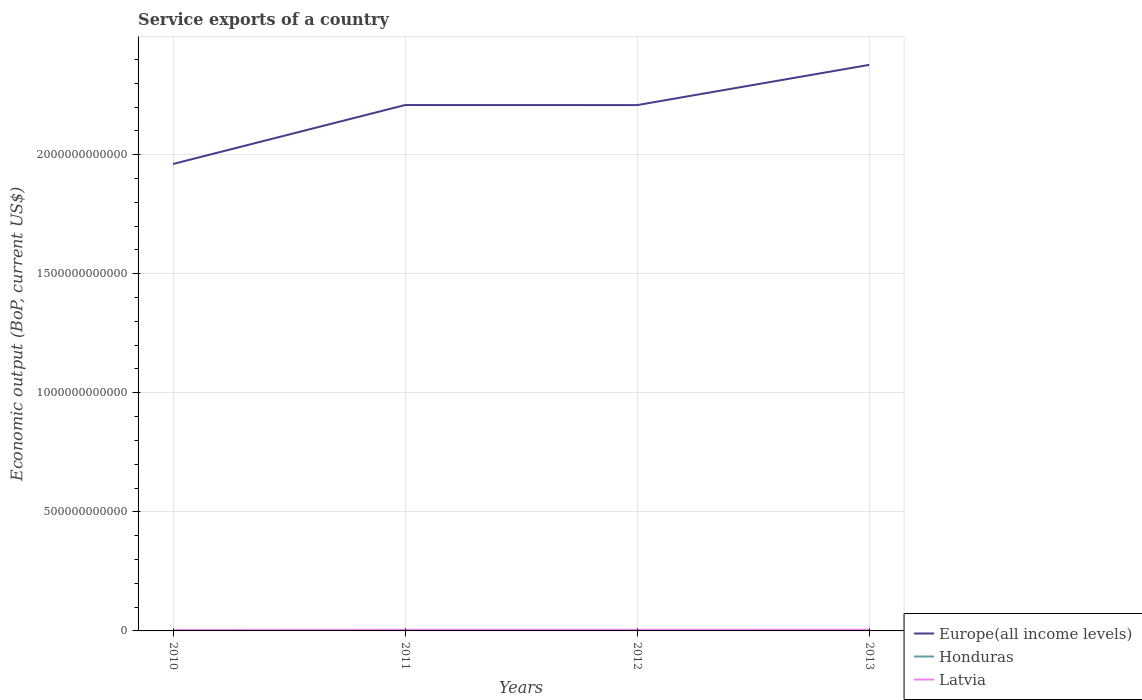Is the number of lines equal to the number of legend labels?
Your response must be concise. Yes. Across all years, what is the maximum service exports in Europe(all income levels)?
Give a very brief answer. 1.96e+12. In which year was the service exports in Honduras maximum?
Offer a terse response. 2010. What is the total service exports in Honduras in the graph?
Provide a short and direct response. -1.46e+08. What is the difference between the highest and the second highest service exports in Latvia?
Offer a very short reply. 1.14e+09. What is the difference between the highest and the lowest service exports in Latvia?
Provide a succinct answer. 3. Is the service exports in Latvia strictly greater than the service exports in Honduras over the years?
Your answer should be very brief. No. How many lines are there?
Your answer should be compact. 3. What is the difference between two consecutive major ticks on the Y-axis?
Make the answer very short. 5.00e+11. How many legend labels are there?
Ensure brevity in your answer.  3. What is the title of the graph?
Provide a succinct answer. Service exports of a country. What is the label or title of the Y-axis?
Ensure brevity in your answer.  Economic output (BoP, current US$). What is the Economic output (BoP, current US$) in Europe(all income levels) in 2010?
Offer a terse response. 1.96e+12. What is the Economic output (BoP, current US$) of Honduras in 2010?
Provide a succinct answer. 2.11e+09. What is the Economic output (BoP, current US$) in Latvia in 2010?
Ensure brevity in your answer.  4.04e+09. What is the Economic output (BoP, current US$) of Europe(all income levels) in 2011?
Give a very brief answer. 2.21e+12. What is the Economic output (BoP, current US$) in Honduras in 2011?
Provide a succinct answer. 2.25e+09. What is the Economic output (BoP, current US$) of Latvia in 2011?
Offer a very short reply. 4.83e+09. What is the Economic output (BoP, current US$) in Europe(all income levels) in 2012?
Make the answer very short. 2.21e+12. What is the Economic output (BoP, current US$) in Honduras in 2012?
Provide a short and direct response. 2.26e+09. What is the Economic output (BoP, current US$) in Latvia in 2012?
Keep it short and to the point. 4.84e+09. What is the Economic output (BoP, current US$) of Europe(all income levels) in 2013?
Offer a very short reply. 2.38e+12. What is the Economic output (BoP, current US$) of Honduras in 2013?
Provide a succinct answer. 2.42e+09. What is the Economic output (BoP, current US$) of Latvia in 2013?
Give a very brief answer. 5.18e+09. Across all years, what is the maximum Economic output (BoP, current US$) in Europe(all income levels)?
Ensure brevity in your answer.  2.38e+12. Across all years, what is the maximum Economic output (BoP, current US$) of Honduras?
Offer a very short reply. 2.42e+09. Across all years, what is the maximum Economic output (BoP, current US$) of Latvia?
Keep it short and to the point. 5.18e+09. Across all years, what is the minimum Economic output (BoP, current US$) of Europe(all income levels)?
Offer a very short reply. 1.96e+12. Across all years, what is the minimum Economic output (BoP, current US$) in Honduras?
Offer a terse response. 2.11e+09. Across all years, what is the minimum Economic output (BoP, current US$) of Latvia?
Your answer should be compact. 4.04e+09. What is the total Economic output (BoP, current US$) in Europe(all income levels) in the graph?
Your answer should be very brief. 8.75e+12. What is the total Economic output (BoP, current US$) of Honduras in the graph?
Provide a succinct answer. 9.04e+09. What is the total Economic output (BoP, current US$) of Latvia in the graph?
Your response must be concise. 1.89e+1. What is the difference between the Economic output (BoP, current US$) in Europe(all income levels) in 2010 and that in 2011?
Your answer should be very brief. -2.48e+11. What is the difference between the Economic output (BoP, current US$) in Honduras in 2010 and that in 2011?
Ensure brevity in your answer.  -1.46e+08. What is the difference between the Economic output (BoP, current US$) in Latvia in 2010 and that in 2011?
Your answer should be very brief. -7.87e+08. What is the difference between the Economic output (BoP, current US$) in Europe(all income levels) in 2010 and that in 2012?
Offer a terse response. -2.47e+11. What is the difference between the Economic output (BoP, current US$) in Honduras in 2010 and that in 2012?
Ensure brevity in your answer.  -1.50e+08. What is the difference between the Economic output (BoP, current US$) of Latvia in 2010 and that in 2012?
Offer a terse response. -7.97e+08. What is the difference between the Economic output (BoP, current US$) in Europe(all income levels) in 2010 and that in 2013?
Your answer should be very brief. -4.16e+11. What is the difference between the Economic output (BoP, current US$) in Honduras in 2010 and that in 2013?
Offer a terse response. -3.17e+08. What is the difference between the Economic output (BoP, current US$) in Latvia in 2010 and that in 2013?
Ensure brevity in your answer.  -1.14e+09. What is the difference between the Economic output (BoP, current US$) in Europe(all income levels) in 2011 and that in 2012?
Offer a very short reply. 3.03e+08. What is the difference between the Economic output (BoP, current US$) of Honduras in 2011 and that in 2012?
Ensure brevity in your answer.  -3.58e+06. What is the difference between the Economic output (BoP, current US$) in Latvia in 2011 and that in 2012?
Your answer should be compact. -1.06e+07. What is the difference between the Economic output (BoP, current US$) of Europe(all income levels) in 2011 and that in 2013?
Ensure brevity in your answer.  -1.69e+11. What is the difference between the Economic output (BoP, current US$) of Honduras in 2011 and that in 2013?
Give a very brief answer. -1.71e+08. What is the difference between the Economic output (BoP, current US$) in Latvia in 2011 and that in 2013?
Offer a terse response. -3.54e+08. What is the difference between the Economic output (BoP, current US$) of Europe(all income levels) in 2012 and that in 2013?
Ensure brevity in your answer.  -1.69e+11. What is the difference between the Economic output (BoP, current US$) of Honduras in 2012 and that in 2013?
Your answer should be very brief. -1.67e+08. What is the difference between the Economic output (BoP, current US$) of Latvia in 2012 and that in 2013?
Your answer should be very brief. -3.43e+08. What is the difference between the Economic output (BoP, current US$) of Europe(all income levels) in 2010 and the Economic output (BoP, current US$) of Honduras in 2011?
Make the answer very short. 1.96e+12. What is the difference between the Economic output (BoP, current US$) in Europe(all income levels) in 2010 and the Economic output (BoP, current US$) in Latvia in 2011?
Provide a succinct answer. 1.96e+12. What is the difference between the Economic output (BoP, current US$) in Honduras in 2010 and the Economic output (BoP, current US$) in Latvia in 2011?
Offer a terse response. -2.72e+09. What is the difference between the Economic output (BoP, current US$) of Europe(all income levels) in 2010 and the Economic output (BoP, current US$) of Honduras in 2012?
Give a very brief answer. 1.96e+12. What is the difference between the Economic output (BoP, current US$) in Europe(all income levels) in 2010 and the Economic output (BoP, current US$) in Latvia in 2012?
Provide a short and direct response. 1.96e+12. What is the difference between the Economic output (BoP, current US$) of Honduras in 2010 and the Economic output (BoP, current US$) of Latvia in 2012?
Give a very brief answer. -2.73e+09. What is the difference between the Economic output (BoP, current US$) of Europe(all income levels) in 2010 and the Economic output (BoP, current US$) of Honduras in 2013?
Provide a succinct answer. 1.96e+12. What is the difference between the Economic output (BoP, current US$) of Europe(all income levels) in 2010 and the Economic output (BoP, current US$) of Latvia in 2013?
Your answer should be very brief. 1.96e+12. What is the difference between the Economic output (BoP, current US$) in Honduras in 2010 and the Economic output (BoP, current US$) in Latvia in 2013?
Keep it short and to the point. -3.07e+09. What is the difference between the Economic output (BoP, current US$) of Europe(all income levels) in 2011 and the Economic output (BoP, current US$) of Honduras in 2012?
Give a very brief answer. 2.21e+12. What is the difference between the Economic output (BoP, current US$) of Europe(all income levels) in 2011 and the Economic output (BoP, current US$) of Latvia in 2012?
Give a very brief answer. 2.20e+12. What is the difference between the Economic output (BoP, current US$) in Honduras in 2011 and the Economic output (BoP, current US$) in Latvia in 2012?
Offer a terse response. -2.58e+09. What is the difference between the Economic output (BoP, current US$) in Europe(all income levels) in 2011 and the Economic output (BoP, current US$) in Honduras in 2013?
Your response must be concise. 2.21e+12. What is the difference between the Economic output (BoP, current US$) of Europe(all income levels) in 2011 and the Economic output (BoP, current US$) of Latvia in 2013?
Give a very brief answer. 2.20e+12. What is the difference between the Economic output (BoP, current US$) in Honduras in 2011 and the Economic output (BoP, current US$) in Latvia in 2013?
Make the answer very short. -2.93e+09. What is the difference between the Economic output (BoP, current US$) of Europe(all income levels) in 2012 and the Economic output (BoP, current US$) of Honduras in 2013?
Give a very brief answer. 2.21e+12. What is the difference between the Economic output (BoP, current US$) of Europe(all income levels) in 2012 and the Economic output (BoP, current US$) of Latvia in 2013?
Make the answer very short. 2.20e+12. What is the difference between the Economic output (BoP, current US$) in Honduras in 2012 and the Economic output (BoP, current US$) in Latvia in 2013?
Keep it short and to the point. -2.92e+09. What is the average Economic output (BoP, current US$) of Europe(all income levels) per year?
Your answer should be compact. 2.19e+12. What is the average Economic output (BoP, current US$) in Honduras per year?
Your answer should be very brief. 2.26e+09. What is the average Economic output (BoP, current US$) of Latvia per year?
Provide a succinct answer. 4.72e+09. In the year 2010, what is the difference between the Economic output (BoP, current US$) of Europe(all income levels) and Economic output (BoP, current US$) of Honduras?
Provide a succinct answer. 1.96e+12. In the year 2010, what is the difference between the Economic output (BoP, current US$) in Europe(all income levels) and Economic output (BoP, current US$) in Latvia?
Provide a succinct answer. 1.96e+12. In the year 2010, what is the difference between the Economic output (BoP, current US$) of Honduras and Economic output (BoP, current US$) of Latvia?
Give a very brief answer. -1.93e+09. In the year 2011, what is the difference between the Economic output (BoP, current US$) of Europe(all income levels) and Economic output (BoP, current US$) of Honduras?
Your answer should be compact. 2.21e+12. In the year 2011, what is the difference between the Economic output (BoP, current US$) of Europe(all income levels) and Economic output (BoP, current US$) of Latvia?
Your response must be concise. 2.20e+12. In the year 2011, what is the difference between the Economic output (BoP, current US$) of Honduras and Economic output (BoP, current US$) of Latvia?
Provide a short and direct response. -2.57e+09. In the year 2012, what is the difference between the Economic output (BoP, current US$) of Europe(all income levels) and Economic output (BoP, current US$) of Honduras?
Keep it short and to the point. 2.21e+12. In the year 2012, what is the difference between the Economic output (BoP, current US$) of Europe(all income levels) and Economic output (BoP, current US$) of Latvia?
Offer a terse response. 2.20e+12. In the year 2012, what is the difference between the Economic output (BoP, current US$) of Honduras and Economic output (BoP, current US$) of Latvia?
Provide a succinct answer. -2.58e+09. In the year 2013, what is the difference between the Economic output (BoP, current US$) in Europe(all income levels) and Economic output (BoP, current US$) in Honduras?
Offer a terse response. 2.37e+12. In the year 2013, what is the difference between the Economic output (BoP, current US$) in Europe(all income levels) and Economic output (BoP, current US$) in Latvia?
Provide a short and direct response. 2.37e+12. In the year 2013, what is the difference between the Economic output (BoP, current US$) of Honduras and Economic output (BoP, current US$) of Latvia?
Give a very brief answer. -2.76e+09. What is the ratio of the Economic output (BoP, current US$) in Europe(all income levels) in 2010 to that in 2011?
Your response must be concise. 0.89. What is the ratio of the Economic output (BoP, current US$) in Honduras in 2010 to that in 2011?
Your answer should be very brief. 0.94. What is the ratio of the Economic output (BoP, current US$) of Latvia in 2010 to that in 2011?
Provide a short and direct response. 0.84. What is the ratio of the Economic output (BoP, current US$) of Europe(all income levels) in 2010 to that in 2012?
Your answer should be compact. 0.89. What is the ratio of the Economic output (BoP, current US$) in Honduras in 2010 to that in 2012?
Your answer should be very brief. 0.93. What is the ratio of the Economic output (BoP, current US$) of Latvia in 2010 to that in 2012?
Your response must be concise. 0.84. What is the ratio of the Economic output (BoP, current US$) in Europe(all income levels) in 2010 to that in 2013?
Your answer should be very brief. 0.82. What is the ratio of the Economic output (BoP, current US$) of Honduras in 2010 to that in 2013?
Ensure brevity in your answer.  0.87. What is the ratio of the Economic output (BoP, current US$) in Latvia in 2010 to that in 2013?
Give a very brief answer. 0.78. What is the ratio of the Economic output (BoP, current US$) of Europe(all income levels) in 2011 to that in 2012?
Provide a short and direct response. 1. What is the ratio of the Economic output (BoP, current US$) of Honduras in 2011 to that in 2012?
Make the answer very short. 1. What is the ratio of the Economic output (BoP, current US$) of Europe(all income levels) in 2011 to that in 2013?
Offer a very short reply. 0.93. What is the ratio of the Economic output (BoP, current US$) in Honduras in 2011 to that in 2013?
Your response must be concise. 0.93. What is the ratio of the Economic output (BoP, current US$) of Latvia in 2011 to that in 2013?
Provide a short and direct response. 0.93. What is the ratio of the Economic output (BoP, current US$) of Europe(all income levels) in 2012 to that in 2013?
Provide a short and direct response. 0.93. What is the ratio of the Economic output (BoP, current US$) in Honduras in 2012 to that in 2013?
Ensure brevity in your answer.  0.93. What is the ratio of the Economic output (BoP, current US$) in Latvia in 2012 to that in 2013?
Provide a short and direct response. 0.93. What is the difference between the highest and the second highest Economic output (BoP, current US$) in Europe(all income levels)?
Make the answer very short. 1.69e+11. What is the difference between the highest and the second highest Economic output (BoP, current US$) in Honduras?
Your answer should be compact. 1.67e+08. What is the difference between the highest and the second highest Economic output (BoP, current US$) in Latvia?
Ensure brevity in your answer.  3.43e+08. What is the difference between the highest and the lowest Economic output (BoP, current US$) in Europe(all income levels)?
Offer a terse response. 4.16e+11. What is the difference between the highest and the lowest Economic output (BoP, current US$) of Honduras?
Your response must be concise. 3.17e+08. What is the difference between the highest and the lowest Economic output (BoP, current US$) of Latvia?
Ensure brevity in your answer.  1.14e+09. 